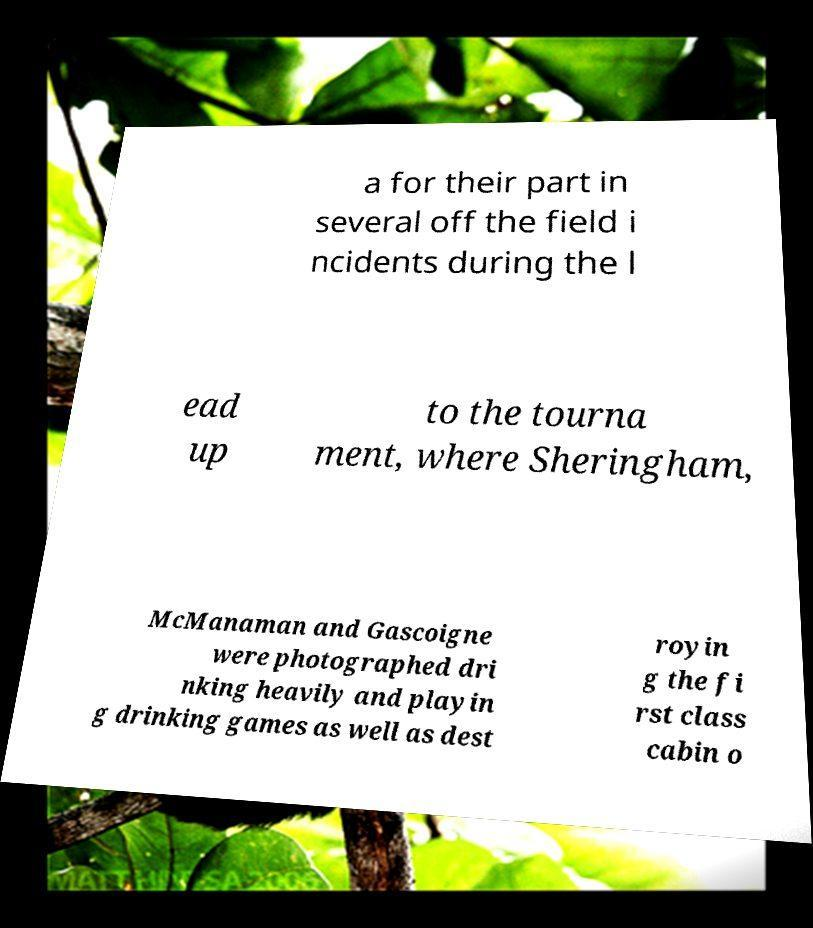Please identify and transcribe the text found in this image. a for their part in several off the field i ncidents during the l ead up to the tourna ment, where Sheringham, McManaman and Gascoigne were photographed dri nking heavily and playin g drinking games as well as dest royin g the fi rst class cabin o 